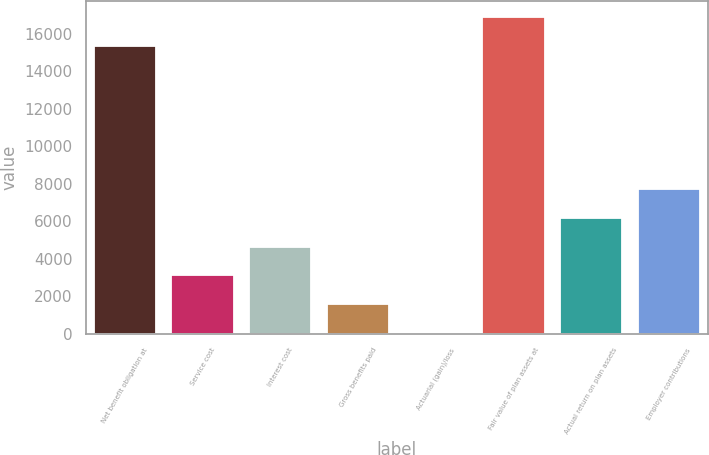Convert chart. <chart><loc_0><loc_0><loc_500><loc_500><bar_chart><fcel>Net benefit obligation at<fcel>Service cost<fcel>Interest cost<fcel>Gross benefits paid<fcel>Actuarial (gain)/loss<fcel>Fair value of plan assets at<fcel>Actual return on plan assets<fcel>Employer contributions<nl><fcel>15363<fcel>3118<fcel>4650<fcel>1586<fcel>54<fcel>16895<fcel>6182<fcel>7714<nl></chart> 